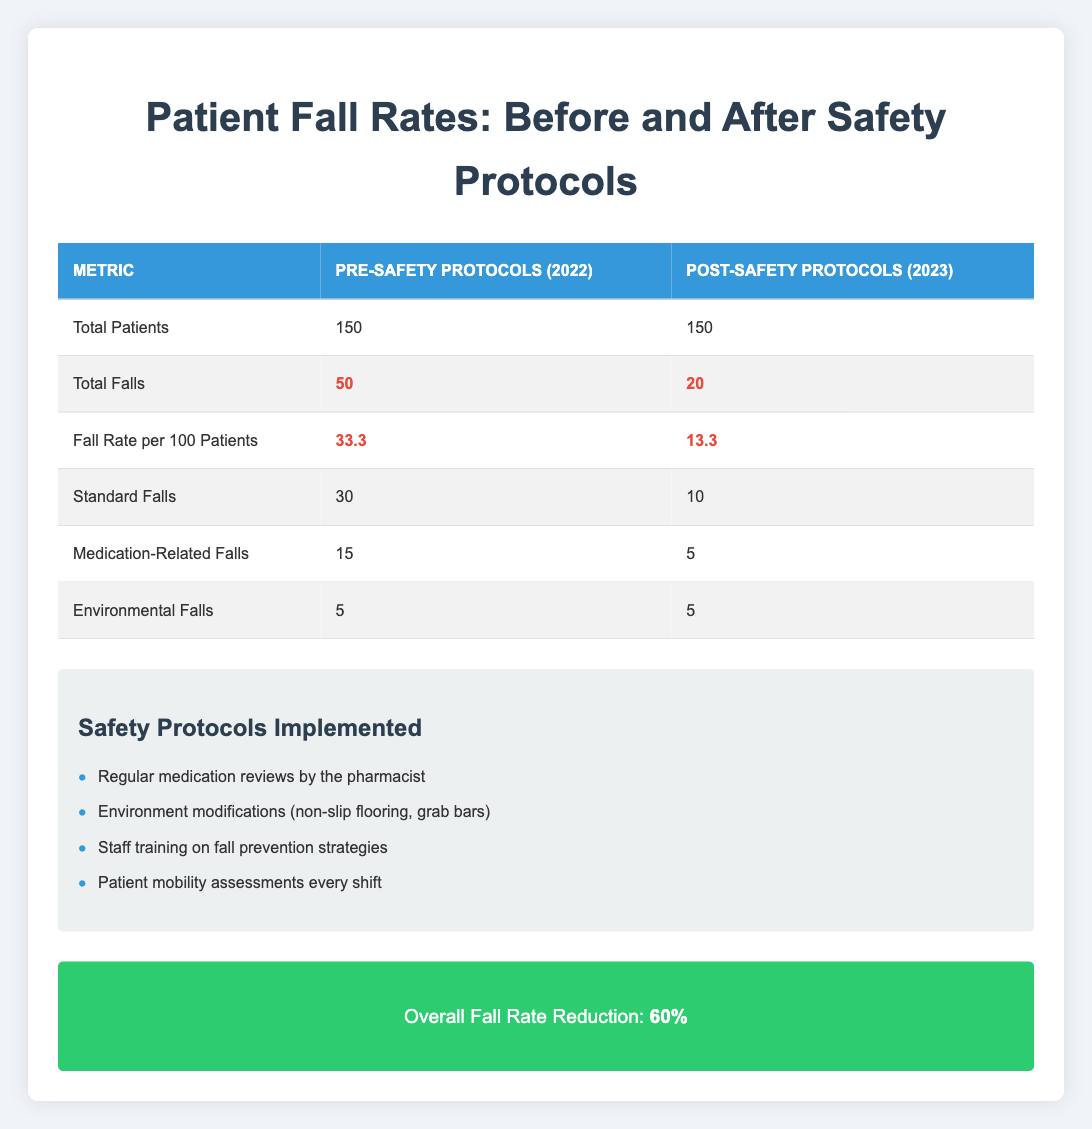What was the total number of falls before implementing the safety protocols? According to the table, under the "Total Falls" metric for the year 2022, the value listed is 50.
Answer: 50 What is the fall rate per 100 patients after implementing the safety protocols? The "Fall Rate per 100 Patients" metric for the year 2023 shows a value of 13.3.
Answer: 13.3 How many medication-related falls occurred before and after the safety protocols were implemented? The table shows that there were 15 medication-related falls in 2022 and 5 in 2023.
Answer: 15 in 2022, 5 in 2023 What is the percentage reduction in the fall rate after implementing the safety protocols? The overall fall rate reduction stated in the improvement section is 60%.
Answer: 60% Did the total number of patients remain the same before and after the safety protocols? Yes, the total number of patients was 150 both in 2022 and 2023, so the statement is true.
Answer: Yes Which type of falls saw a decrease after the safety protocols were implemented? The "Standard Falls" and "Medication-Related Falls" both decreased from 30 to 10 and from 15 to 5, respectively, while "Environmental Falls" remained the same at 5.
Answer: Standard Falls and Medication-Related Falls What is the total number of falls in both 2022 and 2023? Adding the total falls before the safety protocols (50) and after (20) gives a combined total of 70 falls.
Answer: 70 If environmental falls were eliminated, what would be the new total fall count for 2023? The total falls of 20 in 2023 minus the environmental falls of 5 gives a new total of 15 falls if environmental falls were eliminated.
Answer: 15 How many safety protocols were implemented to reduce fall rates? The table lists four specific safety protocols that were implemented for fall prevention.
Answer: 4 